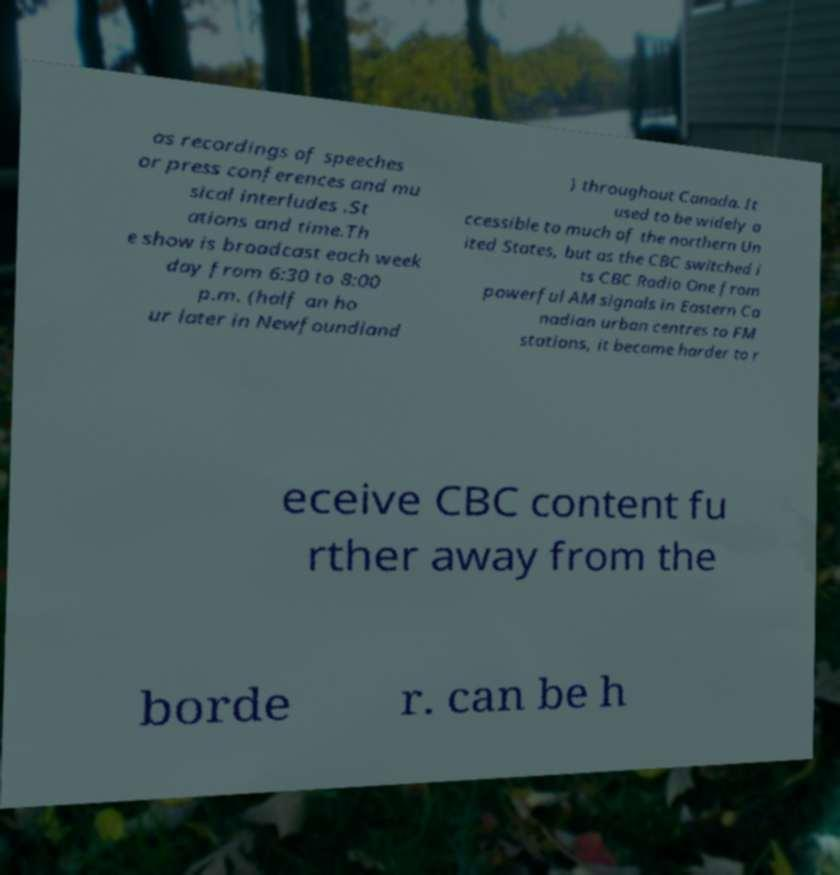For documentation purposes, I need the text within this image transcribed. Could you provide that? as recordings of speeches or press conferences and mu sical interludes .St ations and time.Th e show is broadcast each week day from 6:30 to 8:00 p.m. (half an ho ur later in Newfoundland ) throughout Canada. It used to be widely a ccessible to much of the northern Un ited States, but as the CBC switched i ts CBC Radio One from powerful AM signals in Eastern Ca nadian urban centres to FM stations, it became harder to r eceive CBC content fu rther away from the borde r. can be h 